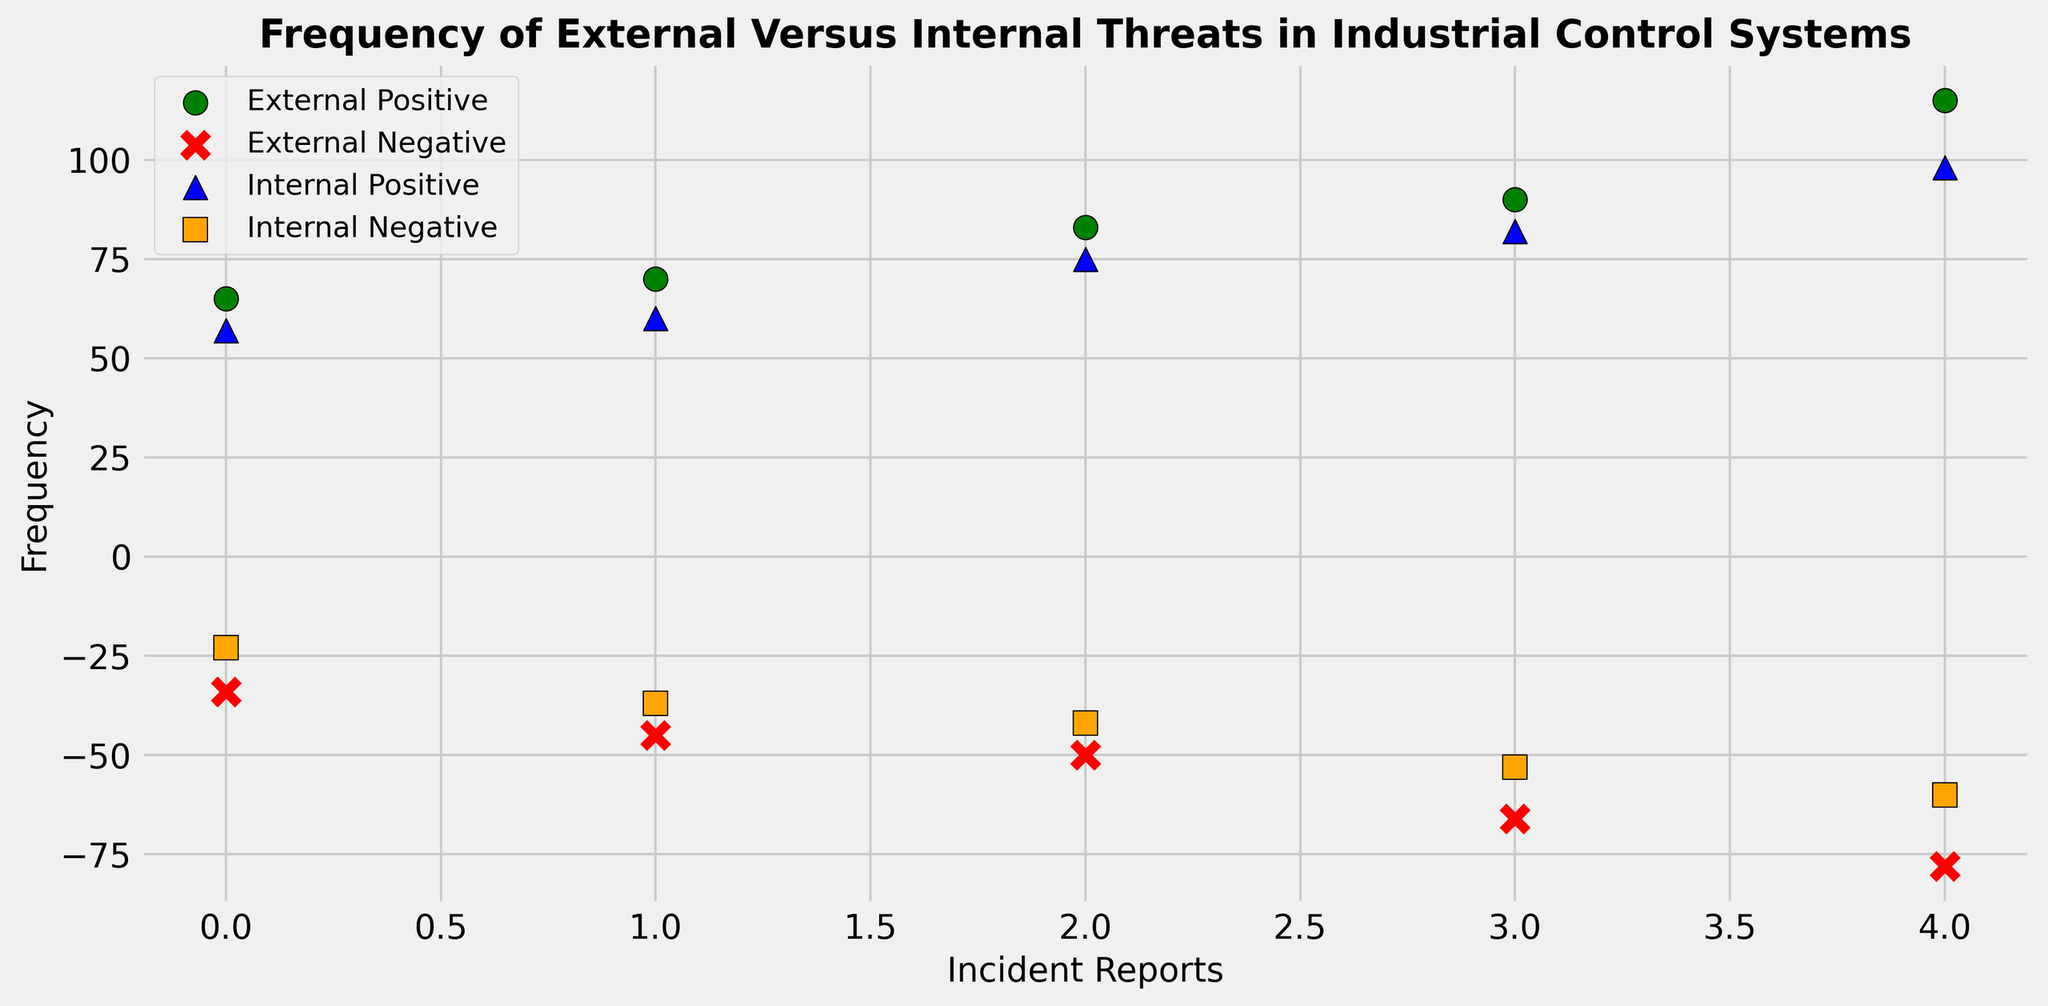How many incident types are there in the scatter plot? The scatter plot differentiates incident types by color and marker shape. There are four unique colors and marker shapes visible.
Answer: 4 Which incident type has the highest positive frequency? The highest positive frequency data point can be identified by looking for the point with the greatest vertical position labeled with the incident type. The green marker (External Positive) reaches the highest positive frequency of 115.
Answer: External Positive What is the total positive frequency for External incidents? Sum up the positive frequency values for External incidents: 65 + 70 + 83 + 90 + 115 = 423.
Answer: 423 Is the highest negative frequency for Internal incidents greater or less than the highest negative frequency for External incidents? Identify the highest negative frequency for both Internal ('orange square') and External ('red x') incidents: Internal is -60 and External is -78. Compare the magnitudes and sign: -60 is less negative than -78.
Answer: Less What is the average positive frequency for Internal incidents? Sum the positive frequency values for Internal incidents: 57 + 60 + 75 + 82 + 98 = 372. Then divide by the number of Internal positive incidents (5): 372 / 5 = 74.4.
Answer: 74.4 How many negative incident reports are there for External threats? Count the number of red x markers on the scatter plot. There are 5 such markers present.
Answer: 5 Which incident type has a higher total negative frequency, External or Internal? Sum the negative frequencies for External (-34, -45, -50, -66, -78 = -273) and Internal incidents (-23, -37, -42, -53, -60 = -215). Compare the totals (ignore the negative sign for this context): -273 is more negative than -215.
Answer: External Which colored markers have the highest and lowest frequencies? Identify the colors of the markers at the highest and lowest frequencies. The highest is green (External Positive) at 115, and the lowest is red (External Negative) at -78.
Answer: Highest: Green, Lowest: Red What is the difference between the highest positive frequency of External incidents and the highest positive frequency of Internal incidents? Subtract the highest positive frequency of Internal incidents (98) from the highest positive frequency of External incidents (115): 115 - 98 = 17.
Answer: 17 